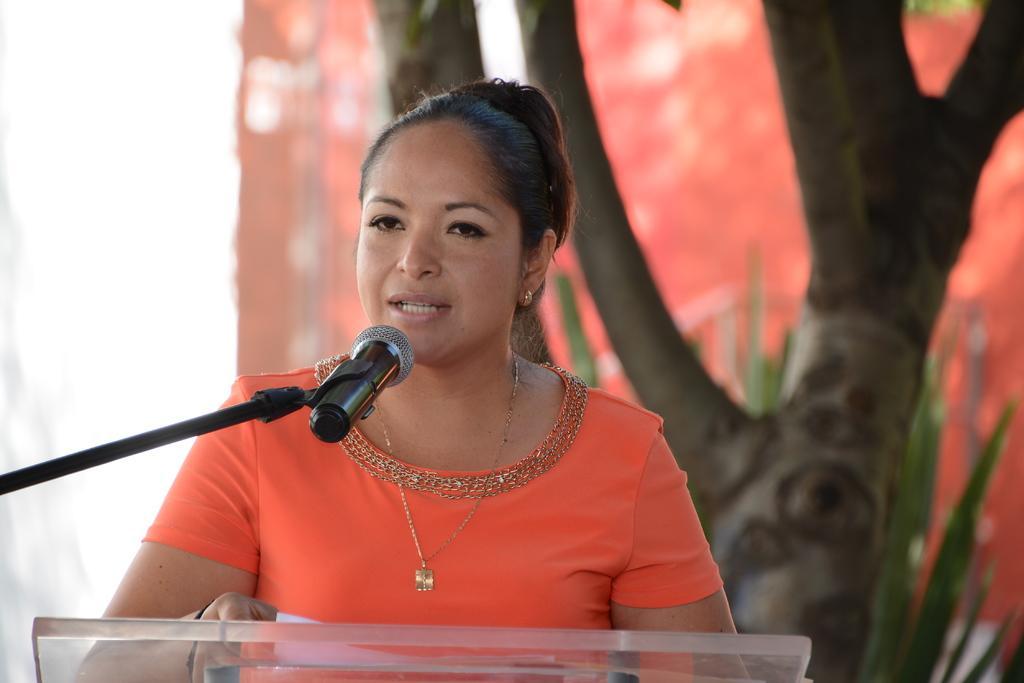Please provide a concise description of this image. In this picture there is a woman wearing orange dress is speaking in front of a mic and there is a tree trunk behind her. 